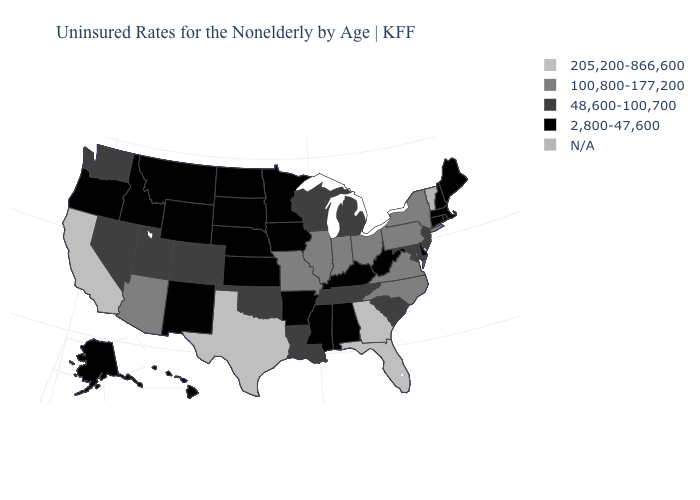Name the states that have a value in the range 48,600-100,700?
Write a very short answer. Colorado, Louisiana, Maryland, Michigan, Nevada, New Jersey, Oklahoma, South Carolina, Tennessee, Utah, Washington, Wisconsin. What is the value of California?
Give a very brief answer. 205,200-866,600. Does Texas have the highest value in the USA?
Concise answer only. Yes. Name the states that have a value in the range 48,600-100,700?
Quick response, please. Colorado, Louisiana, Maryland, Michigan, Nevada, New Jersey, Oklahoma, South Carolina, Tennessee, Utah, Washington, Wisconsin. Which states have the highest value in the USA?
Give a very brief answer. California, Florida, Georgia, Texas. Name the states that have a value in the range 100,800-177,200?
Concise answer only. Arizona, Illinois, Indiana, Missouri, New York, North Carolina, Ohio, Pennsylvania, Virginia. Name the states that have a value in the range 48,600-100,700?
Be succinct. Colorado, Louisiana, Maryland, Michigan, Nevada, New Jersey, Oklahoma, South Carolina, Tennessee, Utah, Washington, Wisconsin. What is the highest value in the MidWest ?
Write a very short answer. 100,800-177,200. Does the first symbol in the legend represent the smallest category?
Quick response, please. No. What is the value of Florida?
Keep it brief. 205,200-866,600. What is the value of Minnesota?
Short answer required. 2,800-47,600. What is the lowest value in states that border New Jersey?
Concise answer only. 2,800-47,600. Which states hav the highest value in the West?
Quick response, please. California. Does New Mexico have the lowest value in the USA?
Give a very brief answer. Yes. 